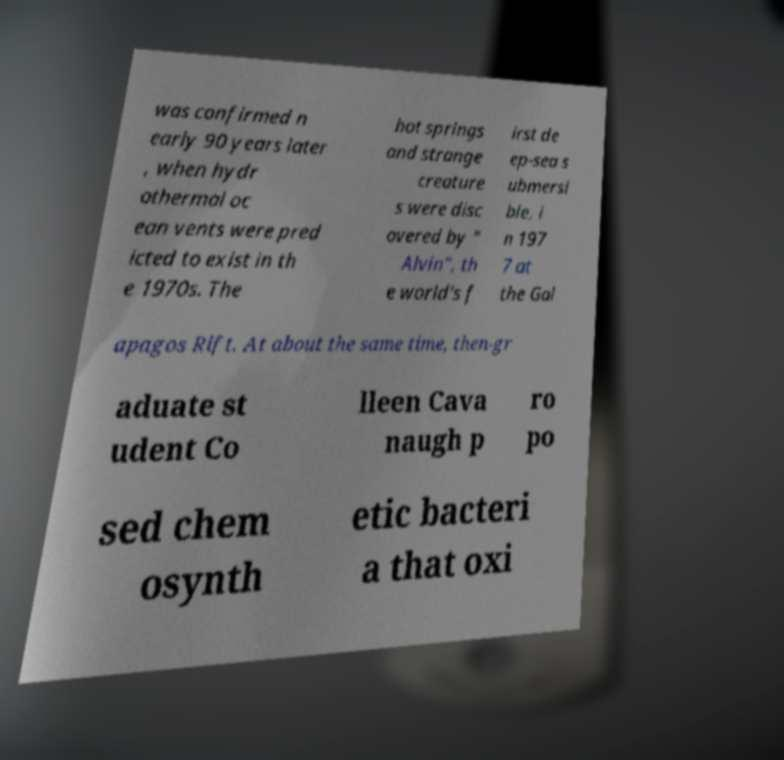For documentation purposes, I need the text within this image transcribed. Could you provide that? was confirmed n early 90 years later , when hydr othermal oc ean vents were pred icted to exist in th e 1970s. The hot springs and strange creature s were disc overed by " Alvin", th e world's f irst de ep-sea s ubmersi ble, i n 197 7 at the Gal apagos Rift. At about the same time, then-gr aduate st udent Co lleen Cava naugh p ro po sed chem osynth etic bacteri a that oxi 